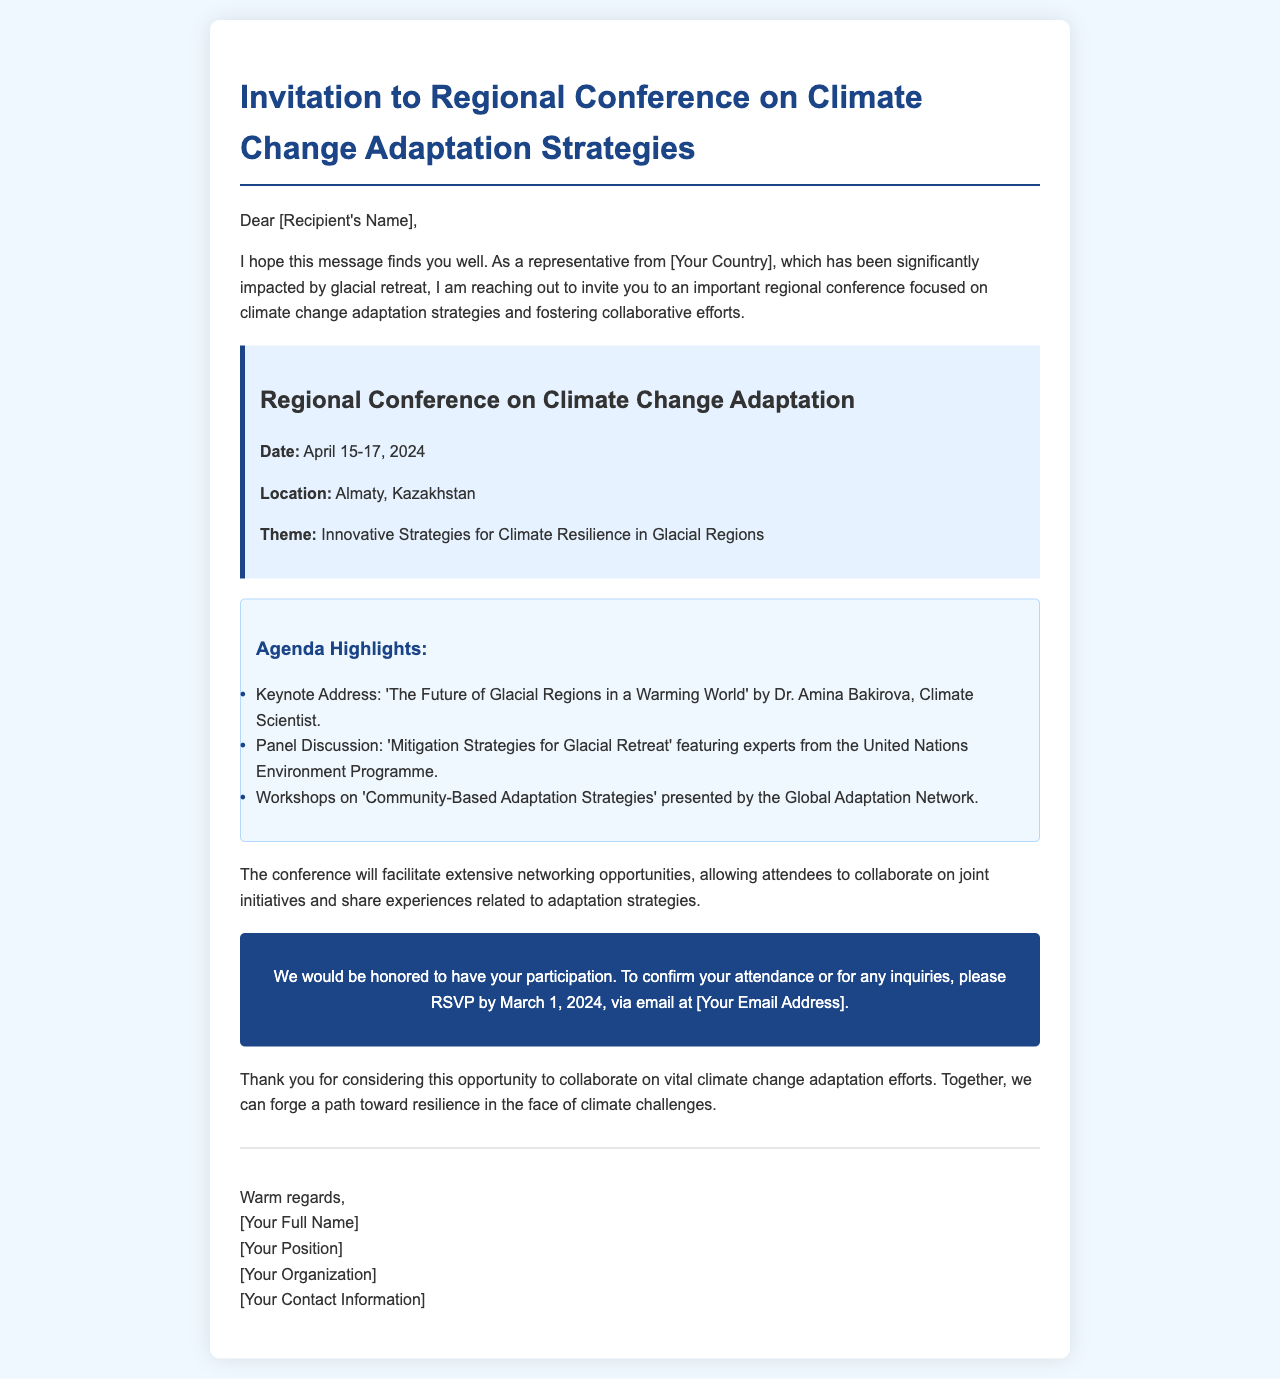What are the dates of the conference? The conference is scheduled from April 15 to April 17, 2024.
Answer: April 15-17, 2024 Where will the conference take place? The location of the conference is specified in the document.
Answer: Almaty, Kazakhstan Who is the keynote speaker? The document lists Dr. Amina Bakirova as the keynote speaker.
Answer: Dr. Amina Bakirova What is the theme of the conference? The document outlines the theme as 'Innovative Strategies for Climate Resilience in Glacial Regions.'
Answer: Innovative Strategies for Climate Resilience in Glacial Regions By when should attendees RSVP? The document indicates the deadline for RSVPs.
Answer: March 1, 2024 What organization is presenting the workshops? The document mentions the Global Adaptation Network will present the workshops.
Answer: Global Adaptation Network What type of content will be discussed in the panel? The panel discussion will focus on strategies to mitigate glacial retreat.
Answer: Mitigation Strategies for Glacial Retreat What is the primary focus of the conference? The primary focus is on climate change adaptation strategies.
Answer: Climate change adaptation strategies 